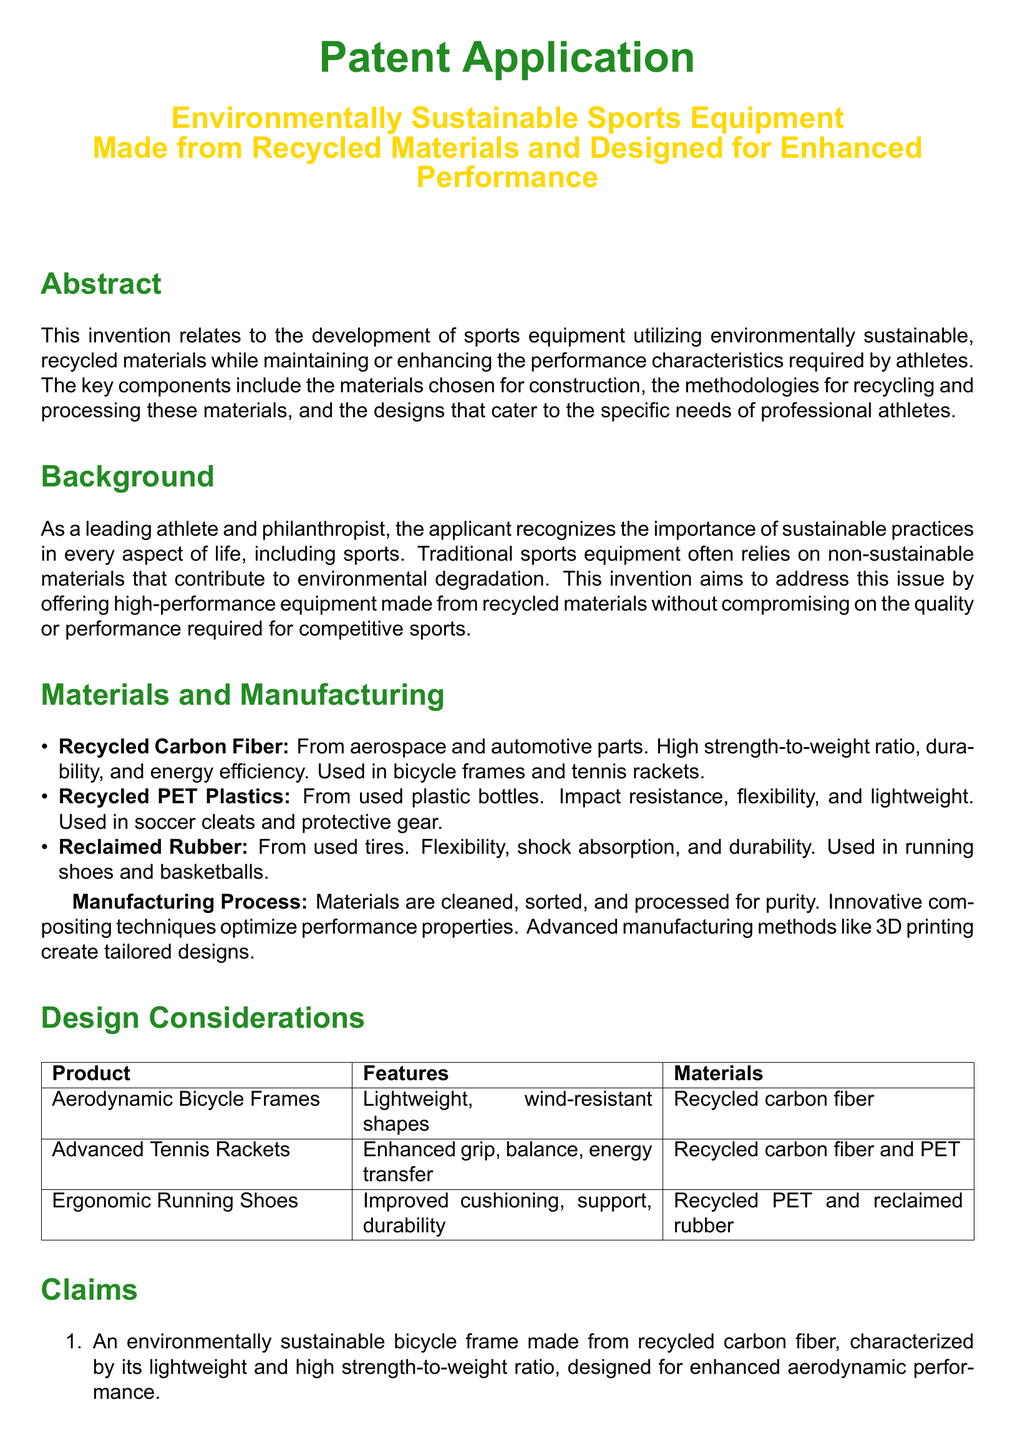What is the main focus of the patent application? The patent application primarily focuses on developing sports equipment using environmentally sustainable materials while enhancing performance characteristics.
Answer: Environmentally sustainable sports equipment Who is the inventor of the patent application? The inventor, as noted in the document, is the individual associated with the development of the invention mentioned.
Answer: Jordan Thompson What type of materials are utilized for the sports equipment? The materials mentioned are specific types that contribute to the construction of the equipment, emphasizing their recycling.
Answer: Recycled materials Which feature does the aerodynamic bicycle frame specifically emphasize? The feature of the aerodynamic bicycle frame is focused on its construction and performance advantages.
Answer: Lightweight and high strength-to-weight ratio From which products is recycled PET plastics sourced? This specifies the source of the material used in the production of certain sports equipment, which reflects environmental sustainability.
Answer: Used plastic bottles What performance characteristic does the advanced tennis racket offer? This characteristic highlights the features added to improve the usability of the tennis racket based on its construction.
Answer: Improved grip, balance, and energy transfer Which manufacturing process is highlighted for optimizing performance properties? This process is essential in ensuring the materials meet the performance standards expected in sports equipment.
Answer: Innovative compositing techniques How many claims are listed in the patent application? This quantifies the number of distinct claims made regarding the sustainable sports equipment inventions.
Answer: Three 